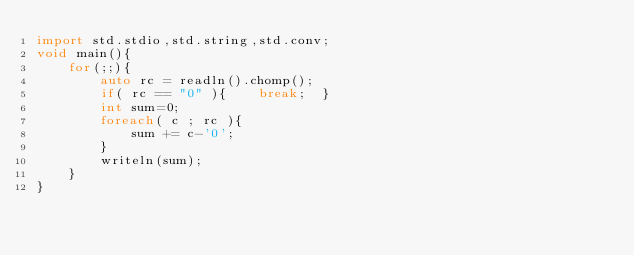<code> <loc_0><loc_0><loc_500><loc_500><_D_>import std.stdio,std.string,std.conv;
void main(){
	for(;;){
		auto rc = readln().chomp();
		if( rc == "0" ){	break;	}
		int sum=0;
		foreach( c ; rc ){
			sum += c-'0';
		}
		writeln(sum);
	}
}</code> 